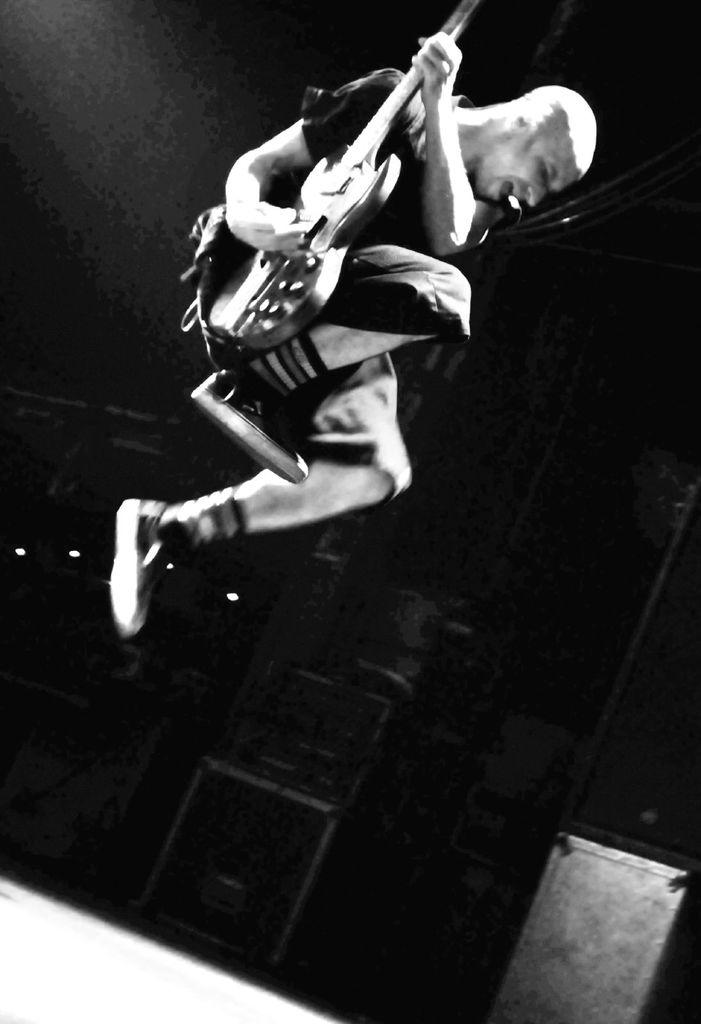Who is the main subject in the picture? There is a person in the center of the picture. What is the person doing in the image? The person is jumping in the air and playing a guitar. What can be observed about the background of the image? The background of the image is dark. What street can be seen in the background of the image? There is no street visible in the background of the image; it is dark. How many men are present in the image? There is only one person in the image, and they are not identified as a man. 